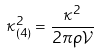<formula> <loc_0><loc_0><loc_500><loc_500>\kappa ^ { 2 } _ { ( 4 ) } = \frac { \kappa ^ { 2 } } { 2 \pi \rho \mathcal { V } }</formula> 